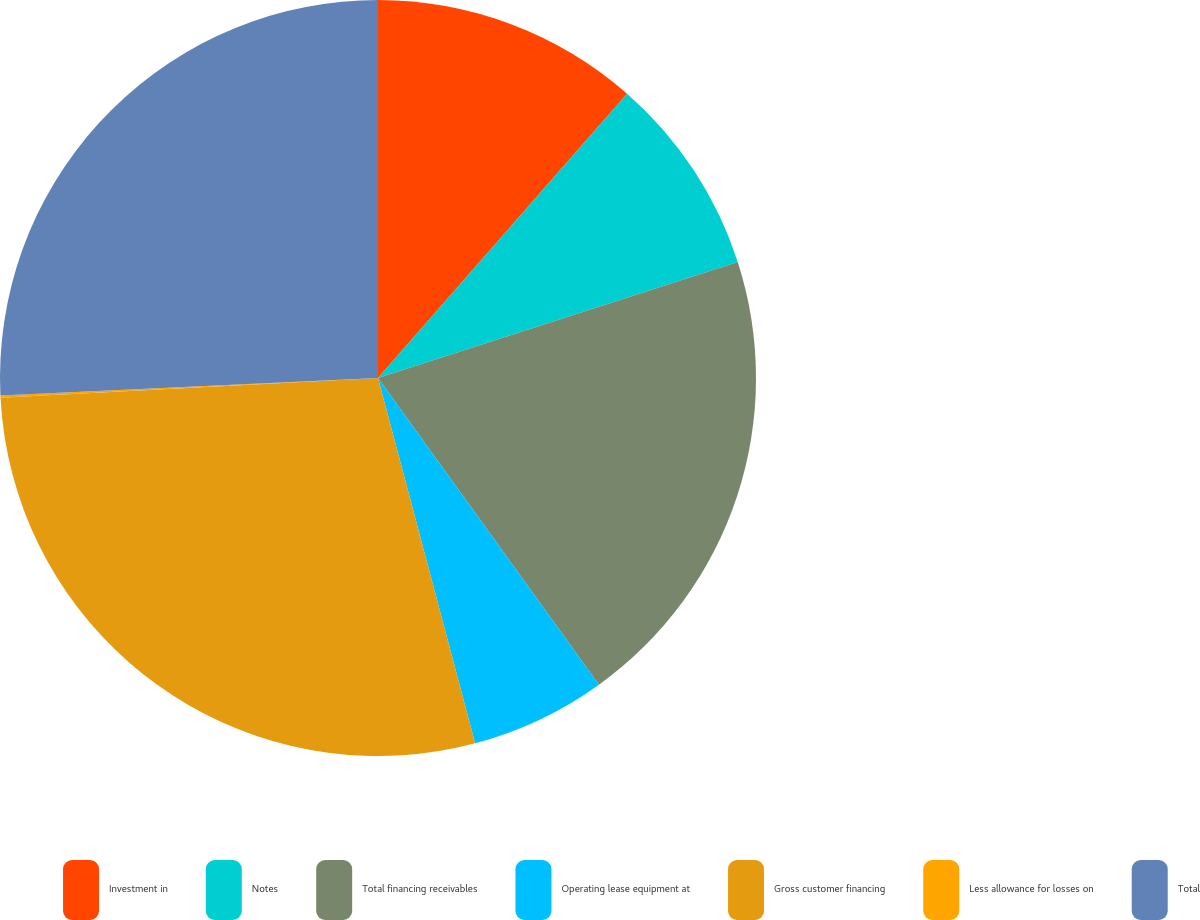<chart> <loc_0><loc_0><loc_500><loc_500><pie_chart><fcel>Investment in<fcel>Notes<fcel>Total financing receivables<fcel>Operating lease equipment at<fcel>Gross customer financing<fcel>Less allowance for losses on<fcel>Total<nl><fcel>11.45%<fcel>8.58%<fcel>20.03%<fcel>5.8%<fcel>28.3%<fcel>0.1%<fcel>25.73%<nl></chart> 